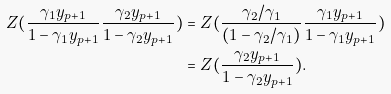Convert formula to latex. <formula><loc_0><loc_0><loc_500><loc_500>Z ( \frac { \gamma _ { 1 } y _ { p + 1 } } { 1 - \gamma _ { 1 } y _ { p + 1 } } \frac { \gamma _ { 2 } y _ { p + 1 } } { 1 - \gamma _ { 2 } y _ { p + 1 } } ) & = Z ( \frac { \gamma _ { 2 } / \gamma _ { 1 } } { ( 1 - \gamma _ { 2 } / \gamma _ { 1 } ) } \frac { \gamma _ { 1 } y _ { p + 1 } } { 1 - \gamma _ { 1 } y _ { p + 1 } } ) \\ & = Z ( \frac { \gamma _ { 2 } y _ { p + 1 } } { 1 - \gamma _ { 2 } y _ { p + 1 } } ) .</formula> 